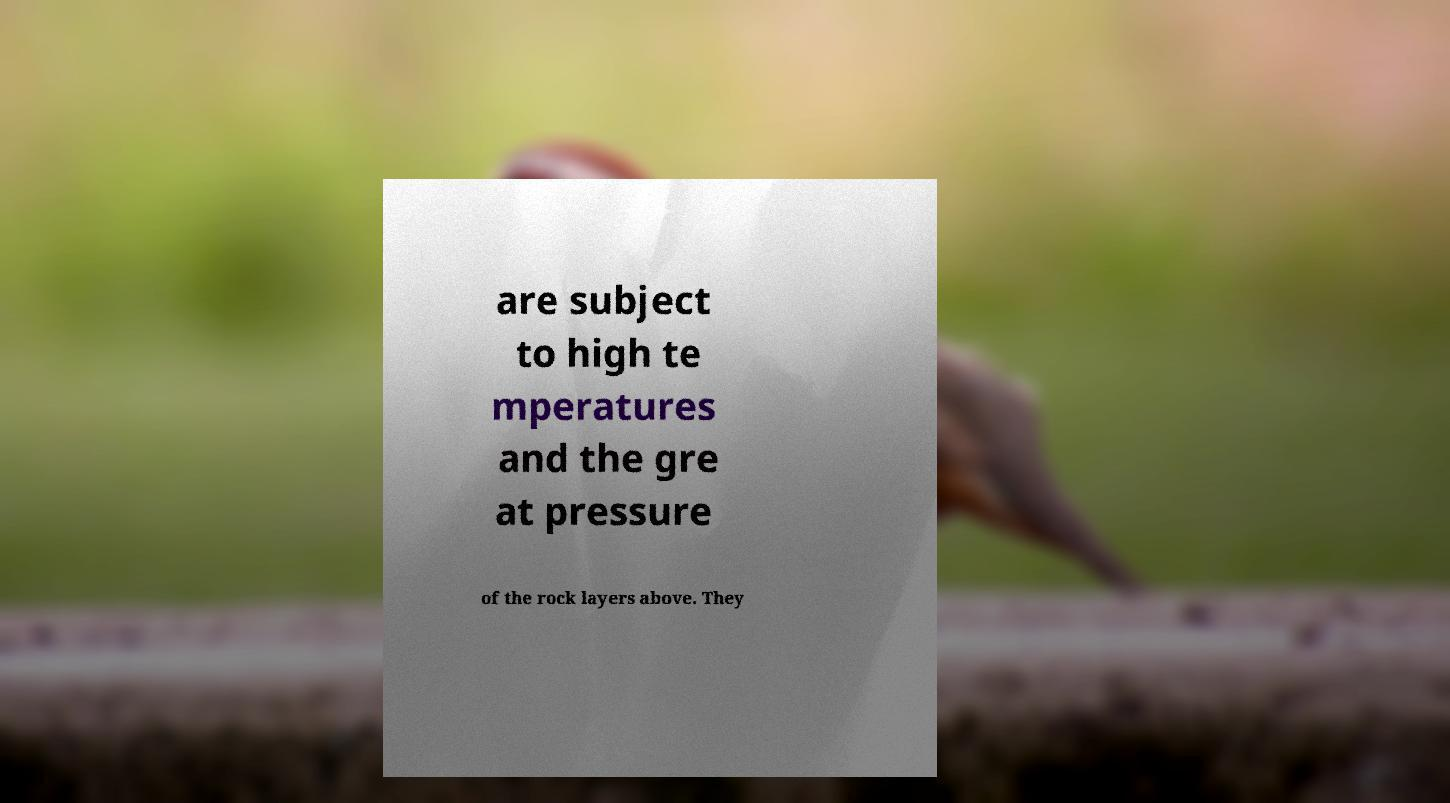For documentation purposes, I need the text within this image transcribed. Could you provide that? are subject to high te mperatures and the gre at pressure of the rock layers above. They 